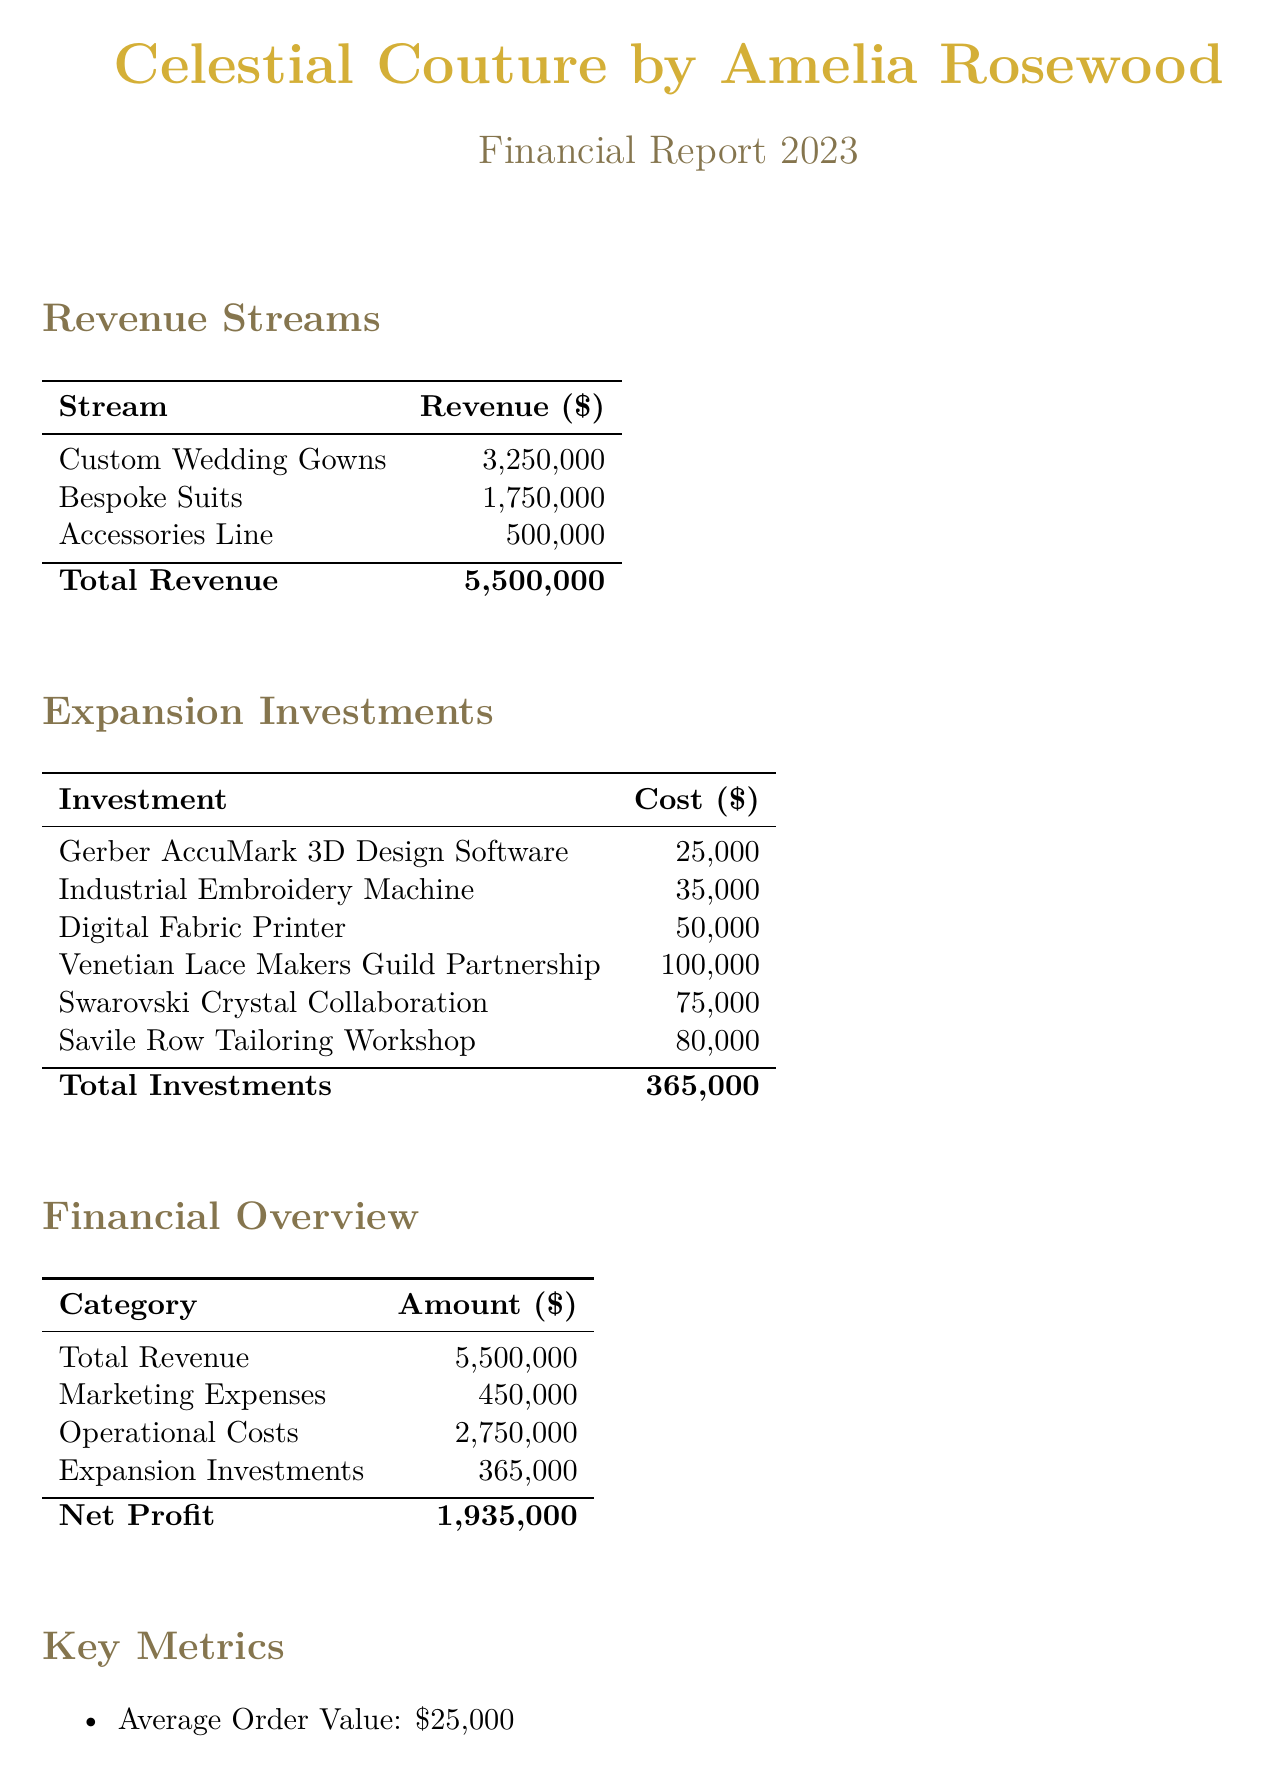What is the total revenue? The total revenue is the sum of all revenue sources in the document: $3,250,000 + $1,750,000 + $500,000 = $5,500,000.
Answer: $5,500,000 What is the cost of the Digital Fabric Printer? The cost of the Digital Fabric Printer is listed under the Design Equipment category in the expansion investments.
Answer: $50,000 What is the total amount spent on Artisan Partnerships? The total for Artisan Partnerships is the sum of the costs of each partnership: $100,000 + $75,000 + $80,000 = $255,000.
Answer: $255,000 What is the projected growth percentage? The projected growth percentage is stated in the Key Metrics section of the document.
Answer: 15% What is the net profit? The net profit is calculated as total revenue minus marketing expenses, operational costs, and expansion investments: $5,500,000 - $450,000 - $2,750,000 - $365,000 = $1,935,000.
Answer: $1,935,000 What equipment is used for 3D design? The equipment used for 3D design is specified under the Design Equipment category.
Answer: Gerber AccuMark 3D Design Software What is the Repeat Customer Rate? The Repeat Customer Rate is provided in the Key Metrics section of the document.
Answer: 30% What is the cost of the Industrial Embroidery Machine? The cost of the Industrial Embroidery Machine is listed in the expansion investments.
Answer: $35,000 